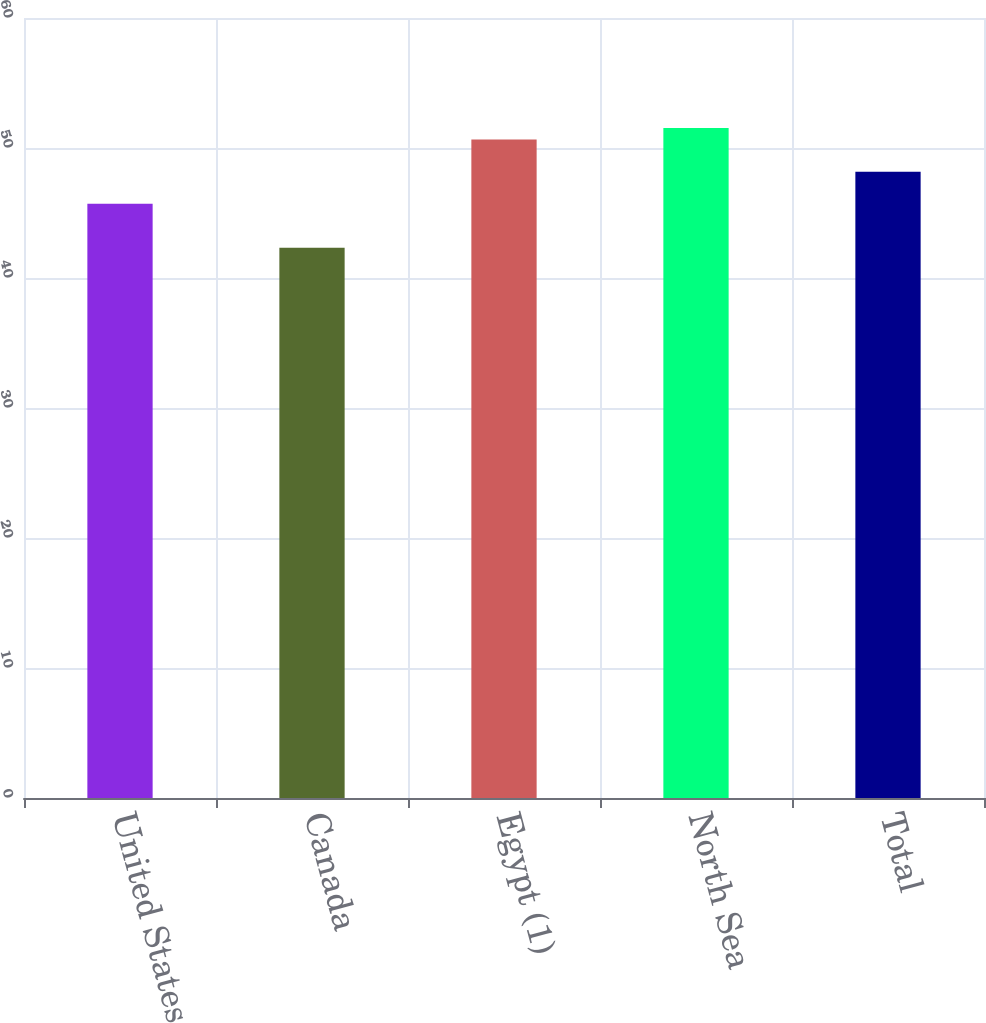<chart> <loc_0><loc_0><loc_500><loc_500><bar_chart><fcel>United States<fcel>Canada<fcel>Egypt (1)<fcel>North Sea<fcel>Total<nl><fcel>45.71<fcel>42.33<fcel>50.65<fcel>51.54<fcel>48.17<nl></chart> 